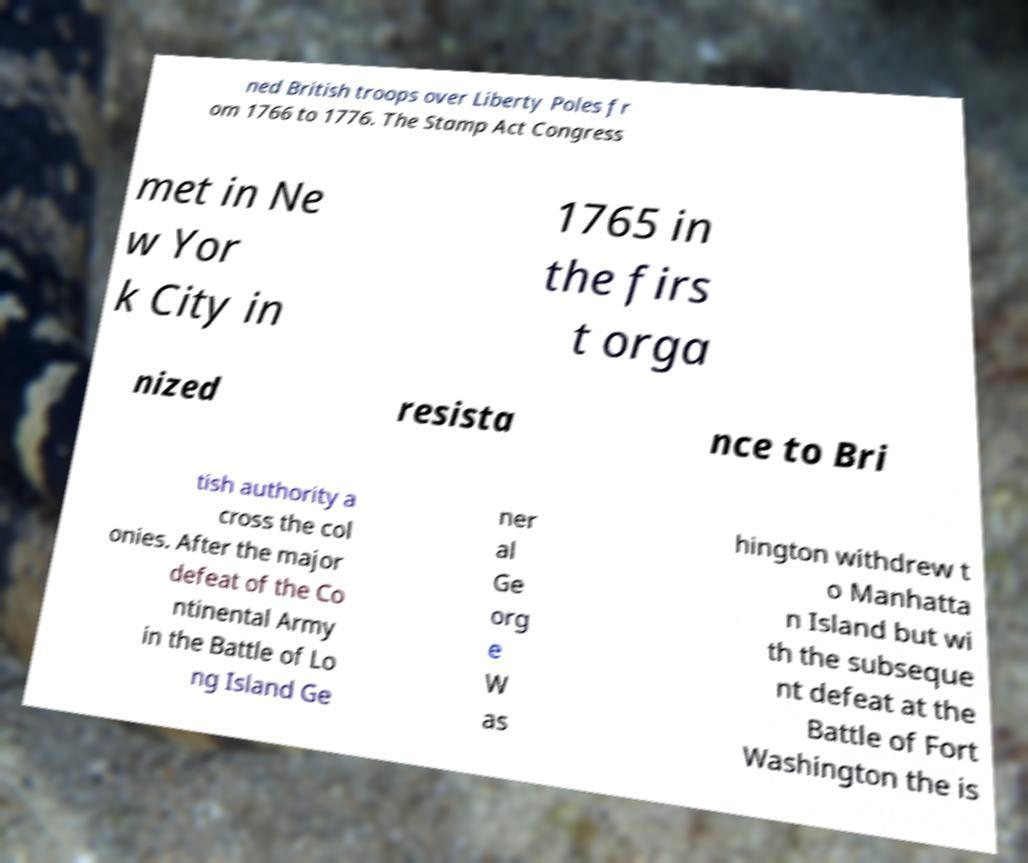Please read and relay the text visible in this image. What does it say? ned British troops over Liberty Poles fr om 1766 to 1776. The Stamp Act Congress met in Ne w Yor k City in 1765 in the firs t orga nized resista nce to Bri tish authority a cross the col onies. After the major defeat of the Co ntinental Army in the Battle of Lo ng Island Ge ner al Ge org e W as hington withdrew t o Manhatta n Island but wi th the subseque nt defeat at the Battle of Fort Washington the is 